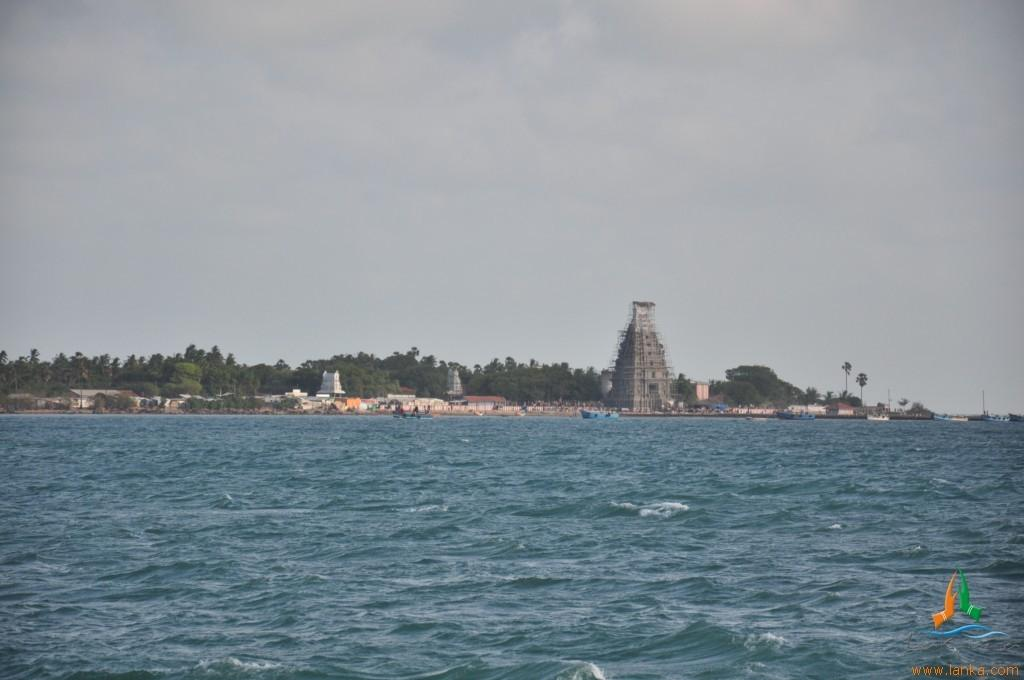What type of vehicles can be seen on the water in the image? There are boats on the water in the image. What type of natural vegetation is visible in the image? Trees are visible in the image. What type of structures are present in the image? Houses and ancient architecture are depicted in the image. What is visible in the background of the image? The sky is visible in the background of the image. Can you tell me how many zebras are standing on the tray in the image? There are no zebras or trays present in the image. What type of vessel is used to transport the ancient architecture in the image? There is no vessel used to transport the ancient architecture in the image; it is depicted as a stationary structure. 